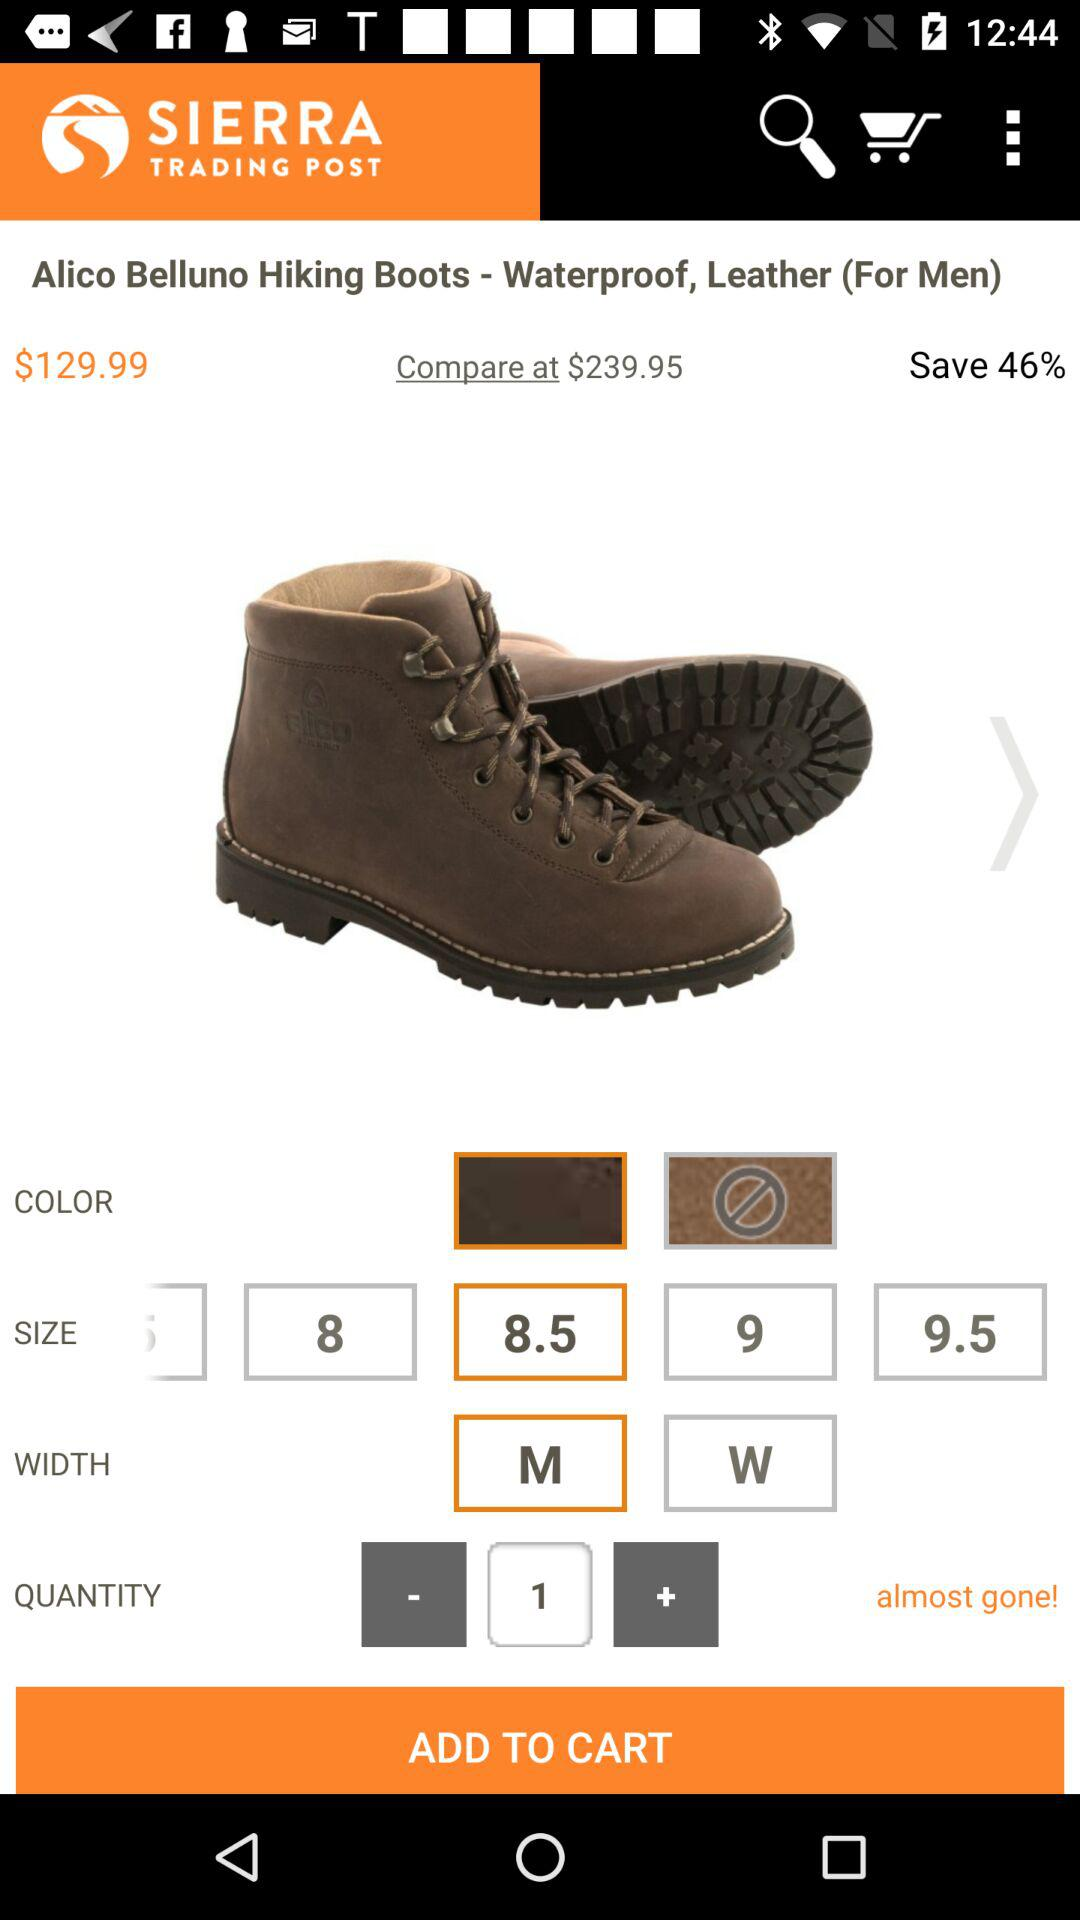What is the selected width? The selected width is "M". 